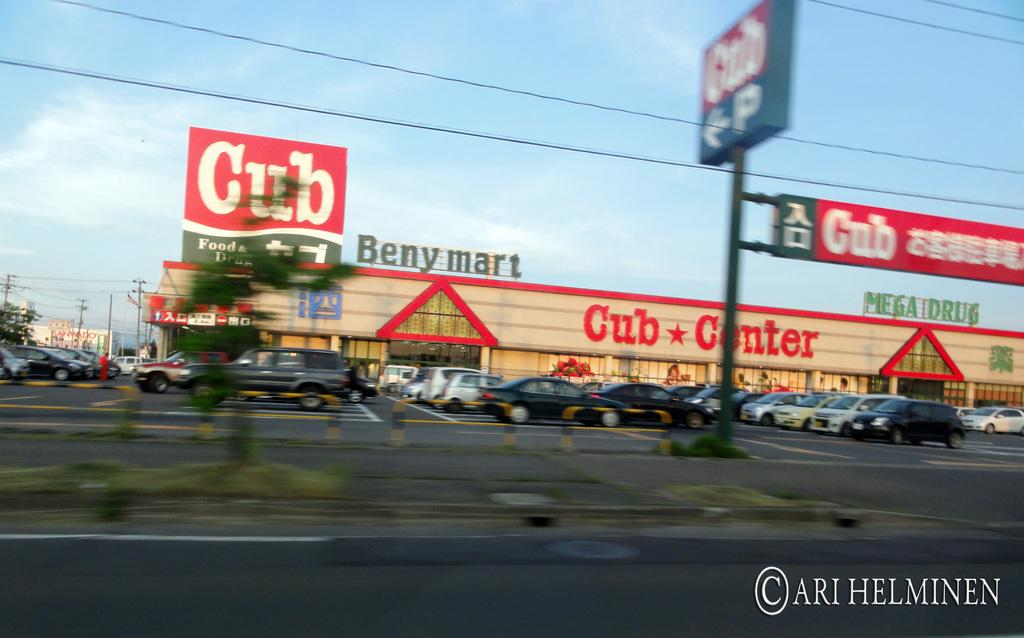Provide a one-sentence caption for the provided image. club center shopping center with lots of cars in pakring lot. 